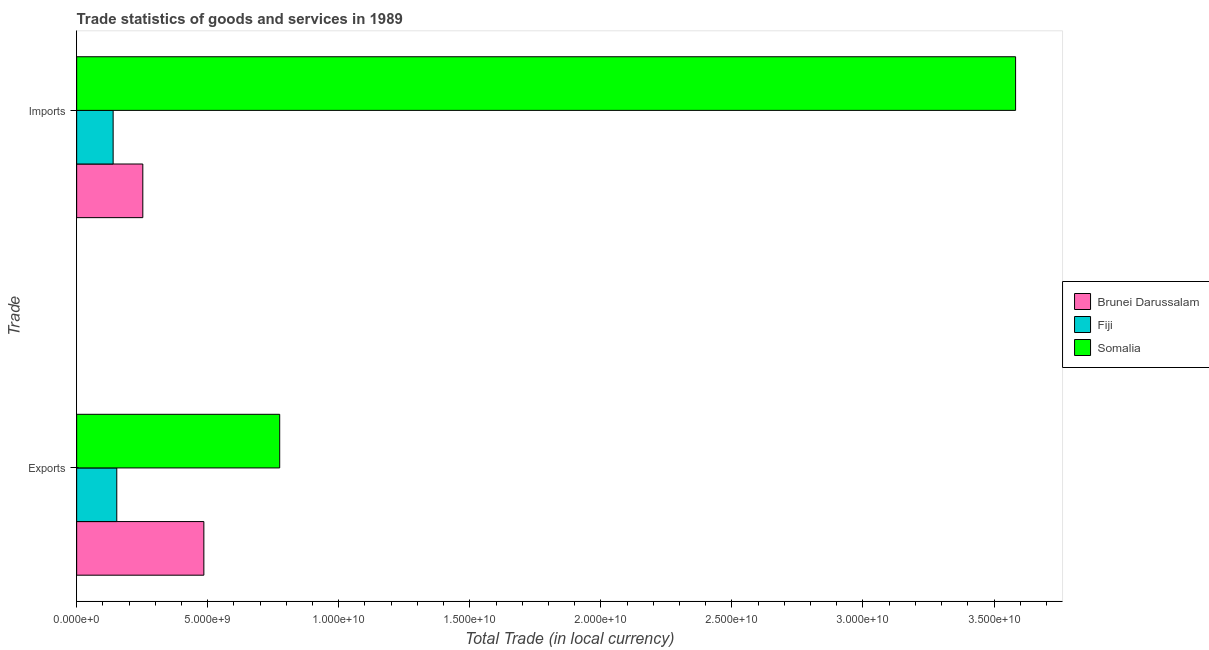Are the number of bars per tick equal to the number of legend labels?
Offer a very short reply. Yes. Are the number of bars on each tick of the Y-axis equal?
Provide a succinct answer. Yes. How many bars are there on the 2nd tick from the bottom?
Your answer should be very brief. 3. What is the label of the 1st group of bars from the top?
Keep it short and to the point. Imports. What is the imports of goods and services in Fiji?
Your answer should be very brief. 1.39e+09. Across all countries, what is the maximum imports of goods and services?
Your answer should be compact. 3.58e+1. Across all countries, what is the minimum imports of goods and services?
Ensure brevity in your answer.  1.39e+09. In which country was the export of goods and services maximum?
Your answer should be compact. Somalia. In which country was the export of goods and services minimum?
Offer a terse response. Fiji. What is the total imports of goods and services in the graph?
Your answer should be very brief. 3.97e+1. What is the difference between the export of goods and services in Fiji and that in Somalia?
Make the answer very short. -6.22e+09. What is the difference between the imports of goods and services in Fiji and the export of goods and services in Brunei Darussalam?
Give a very brief answer. -3.46e+09. What is the average imports of goods and services per country?
Offer a terse response. 1.32e+1. What is the difference between the imports of goods and services and export of goods and services in Brunei Darussalam?
Offer a very short reply. -2.33e+09. What is the ratio of the imports of goods and services in Brunei Darussalam to that in Fiji?
Your answer should be very brief. 1.81. Is the export of goods and services in Brunei Darussalam less than that in Somalia?
Offer a terse response. Yes. In how many countries, is the export of goods and services greater than the average export of goods and services taken over all countries?
Ensure brevity in your answer.  2. What does the 1st bar from the top in Exports represents?
Give a very brief answer. Somalia. What does the 3rd bar from the bottom in Exports represents?
Offer a very short reply. Somalia. How many bars are there?
Offer a very short reply. 6. What is the difference between two consecutive major ticks on the X-axis?
Offer a terse response. 5.00e+09. Are the values on the major ticks of X-axis written in scientific E-notation?
Make the answer very short. Yes. Does the graph contain grids?
Offer a terse response. No. Where does the legend appear in the graph?
Keep it short and to the point. Center right. How many legend labels are there?
Ensure brevity in your answer.  3. What is the title of the graph?
Your answer should be compact. Trade statistics of goods and services in 1989. What is the label or title of the X-axis?
Provide a short and direct response. Total Trade (in local currency). What is the label or title of the Y-axis?
Your answer should be compact. Trade. What is the Total Trade (in local currency) in Brunei Darussalam in Exports?
Offer a terse response. 4.85e+09. What is the Total Trade (in local currency) in Fiji in Exports?
Offer a very short reply. 1.53e+09. What is the Total Trade (in local currency) of Somalia in Exports?
Make the answer very short. 7.75e+09. What is the Total Trade (in local currency) in Brunei Darussalam in Imports?
Keep it short and to the point. 2.52e+09. What is the Total Trade (in local currency) of Fiji in Imports?
Your answer should be very brief. 1.39e+09. What is the Total Trade (in local currency) in Somalia in Imports?
Ensure brevity in your answer.  3.58e+1. Across all Trade, what is the maximum Total Trade (in local currency) of Brunei Darussalam?
Your answer should be compact. 4.85e+09. Across all Trade, what is the maximum Total Trade (in local currency) in Fiji?
Make the answer very short. 1.53e+09. Across all Trade, what is the maximum Total Trade (in local currency) in Somalia?
Your answer should be compact. 3.58e+1. Across all Trade, what is the minimum Total Trade (in local currency) of Brunei Darussalam?
Keep it short and to the point. 2.52e+09. Across all Trade, what is the minimum Total Trade (in local currency) of Fiji?
Your answer should be compact. 1.39e+09. Across all Trade, what is the minimum Total Trade (in local currency) in Somalia?
Provide a succinct answer. 7.75e+09. What is the total Total Trade (in local currency) of Brunei Darussalam in the graph?
Provide a succinct answer. 7.38e+09. What is the total Total Trade (in local currency) in Fiji in the graph?
Provide a succinct answer. 2.92e+09. What is the total Total Trade (in local currency) in Somalia in the graph?
Offer a terse response. 4.36e+1. What is the difference between the Total Trade (in local currency) of Brunei Darussalam in Exports and that in Imports?
Provide a succinct answer. 2.33e+09. What is the difference between the Total Trade (in local currency) of Fiji in Exports and that in Imports?
Your answer should be very brief. 1.39e+08. What is the difference between the Total Trade (in local currency) in Somalia in Exports and that in Imports?
Give a very brief answer. -2.81e+1. What is the difference between the Total Trade (in local currency) of Brunei Darussalam in Exports and the Total Trade (in local currency) of Fiji in Imports?
Keep it short and to the point. 3.46e+09. What is the difference between the Total Trade (in local currency) in Brunei Darussalam in Exports and the Total Trade (in local currency) in Somalia in Imports?
Your answer should be compact. -3.10e+1. What is the difference between the Total Trade (in local currency) in Fiji in Exports and the Total Trade (in local currency) in Somalia in Imports?
Ensure brevity in your answer.  -3.43e+1. What is the average Total Trade (in local currency) in Brunei Darussalam per Trade?
Keep it short and to the point. 3.69e+09. What is the average Total Trade (in local currency) in Fiji per Trade?
Ensure brevity in your answer.  1.46e+09. What is the average Total Trade (in local currency) of Somalia per Trade?
Your response must be concise. 2.18e+1. What is the difference between the Total Trade (in local currency) of Brunei Darussalam and Total Trade (in local currency) of Fiji in Exports?
Provide a succinct answer. 3.32e+09. What is the difference between the Total Trade (in local currency) of Brunei Darussalam and Total Trade (in local currency) of Somalia in Exports?
Provide a short and direct response. -2.89e+09. What is the difference between the Total Trade (in local currency) of Fiji and Total Trade (in local currency) of Somalia in Exports?
Your answer should be very brief. -6.22e+09. What is the difference between the Total Trade (in local currency) of Brunei Darussalam and Total Trade (in local currency) of Fiji in Imports?
Your answer should be very brief. 1.13e+09. What is the difference between the Total Trade (in local currency) of Brunei Darussalam and Total Trade (in local currency) of Somalia in Imports?
Keep it short and to the point. -3.33e+1. What is the difference between the Total Trade (in local currency) of Fiji and Total Trade (in local currency) of Somalia in Imports?
Offer a terse response. -3.44e+1. What is the ratio of the Total Trade (in local currency) of Brunei Darussalam in Exports to that in Imports?
Your response must be concise. 1.92. What is the ratio of the Total Trade (in local currency) of Somalia in Exports to that in Imports?
Make the answer very short. 0.22. What is the difference between the highest and the second highest Total Trade (in local currency) in Brunei Darussalam?
Your answer should be compact. 2.33e+09. What is the difference between the highest and the second highest Total Trade (in local currency) in Fiji?
Give a very brief answer. 1.39e+08. What is the difference between the highest and the second highest Total Trade (in local currency) of Somalia?
Offer a terse response. 2.81e+1. What is the difference between the highest and the lowest Total Trade (in local currency) of Brunei Darussalam?
Give a very brief answer. 2.33e+09. What is the difference between the highest and the lowest Total Trade (in local currency) of Fiji?
Keep it short and to the point. 1.39e+08. What is the difference between the highest and the lowest Total Trade (in local currency) of Somalia?
Ensure brevity in your answer.  2.81e+1. 